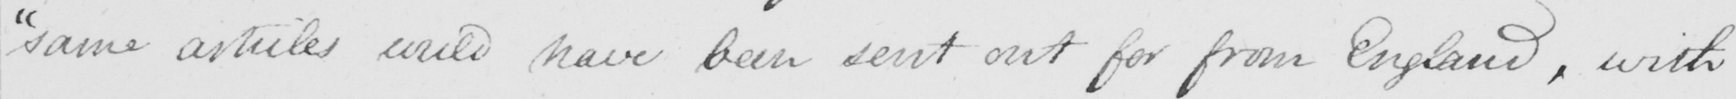Transcribe the text shown in this historical manuscript line. " same articles could have been sent out for from England , with 